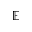Convert formula to latex. <formula><loc_0><loc_0><loc_500><loc_500>\mathbb { E }</formula> 